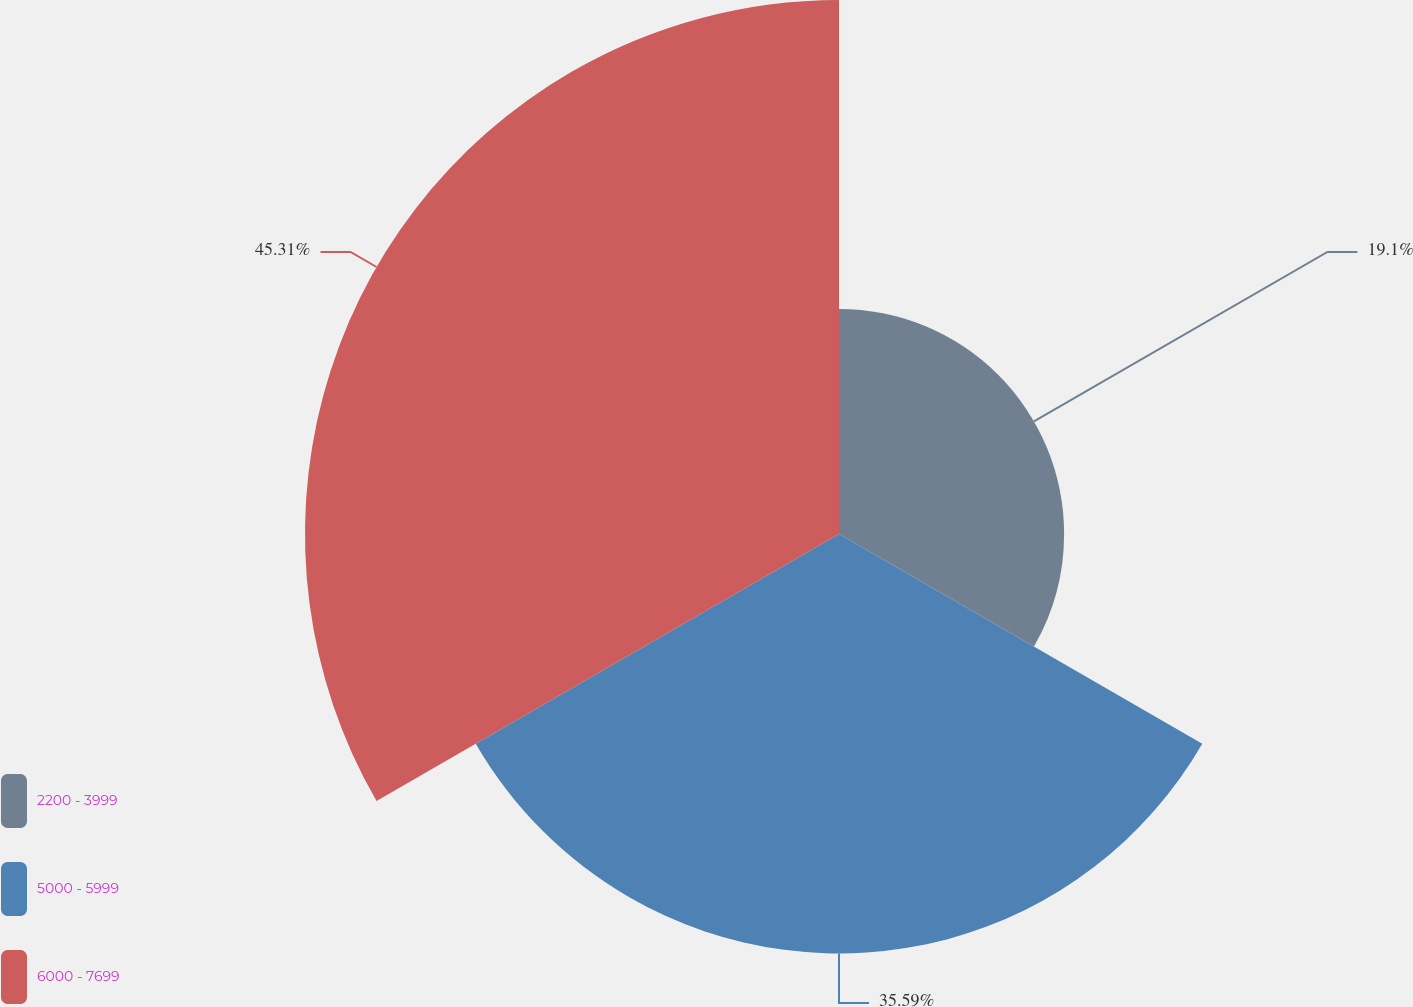Convert chart. <chart><loc_0><loc_0><loc_500><loc_500><pie_chart><fcel>2200 - 3999<fcel>5000 - 5999<fcel>6000 - 7699<nl><fcel>19.1%<fcel>35.59%<fcel>45.31%<nl></chart> 